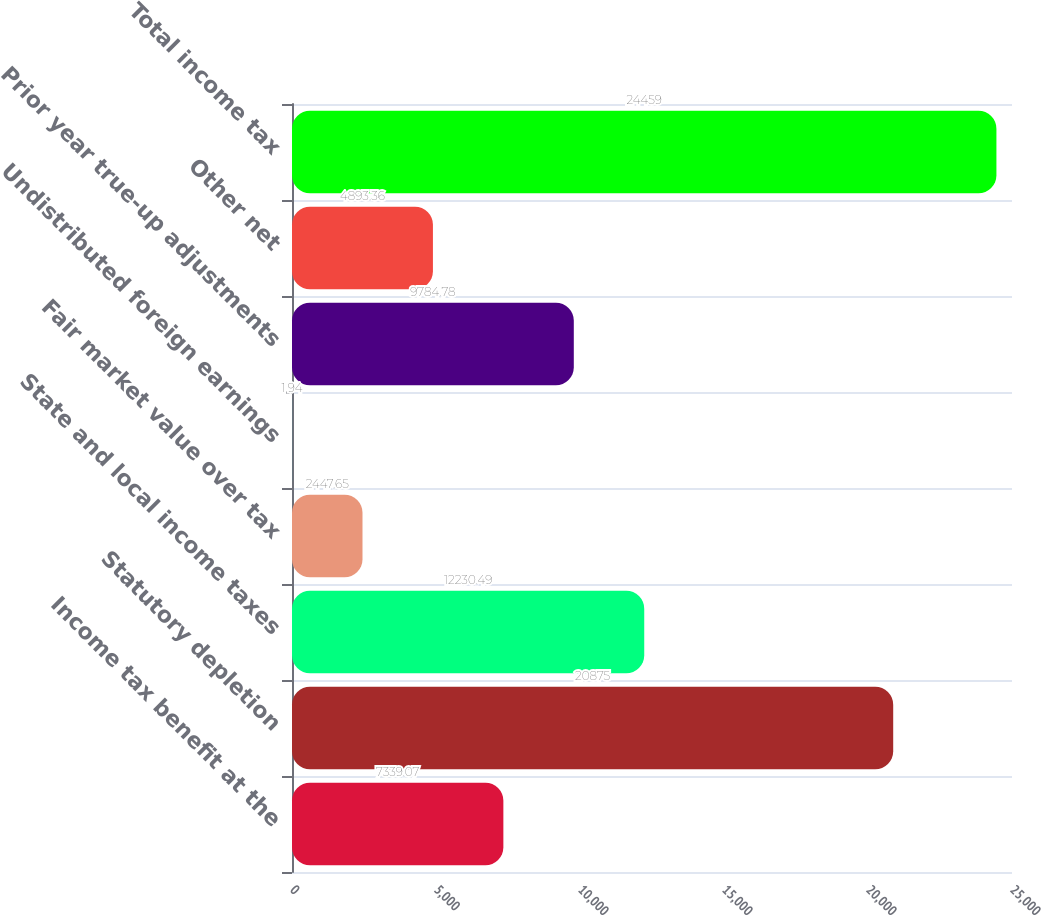<chart> <loc_0><loc_0><loc_500><loc_500><bar_chart><fcel>Income tax benefit at the<fcel>Statutory depletion<fcel>State and local income taxes<fcel>Fair market value over tax<fcel>Undistributed foreign earnings<fcel>Prior year true-up adjustments<fcel>Other net<fcel>Total income tax<nl><fcel>7339.07<fcel>20875<fcel>12230.5<fcel>2447.65<fcel>1.94<fcel>9784.78<fcel>4893.36<fcel>24459<nl></chart> 